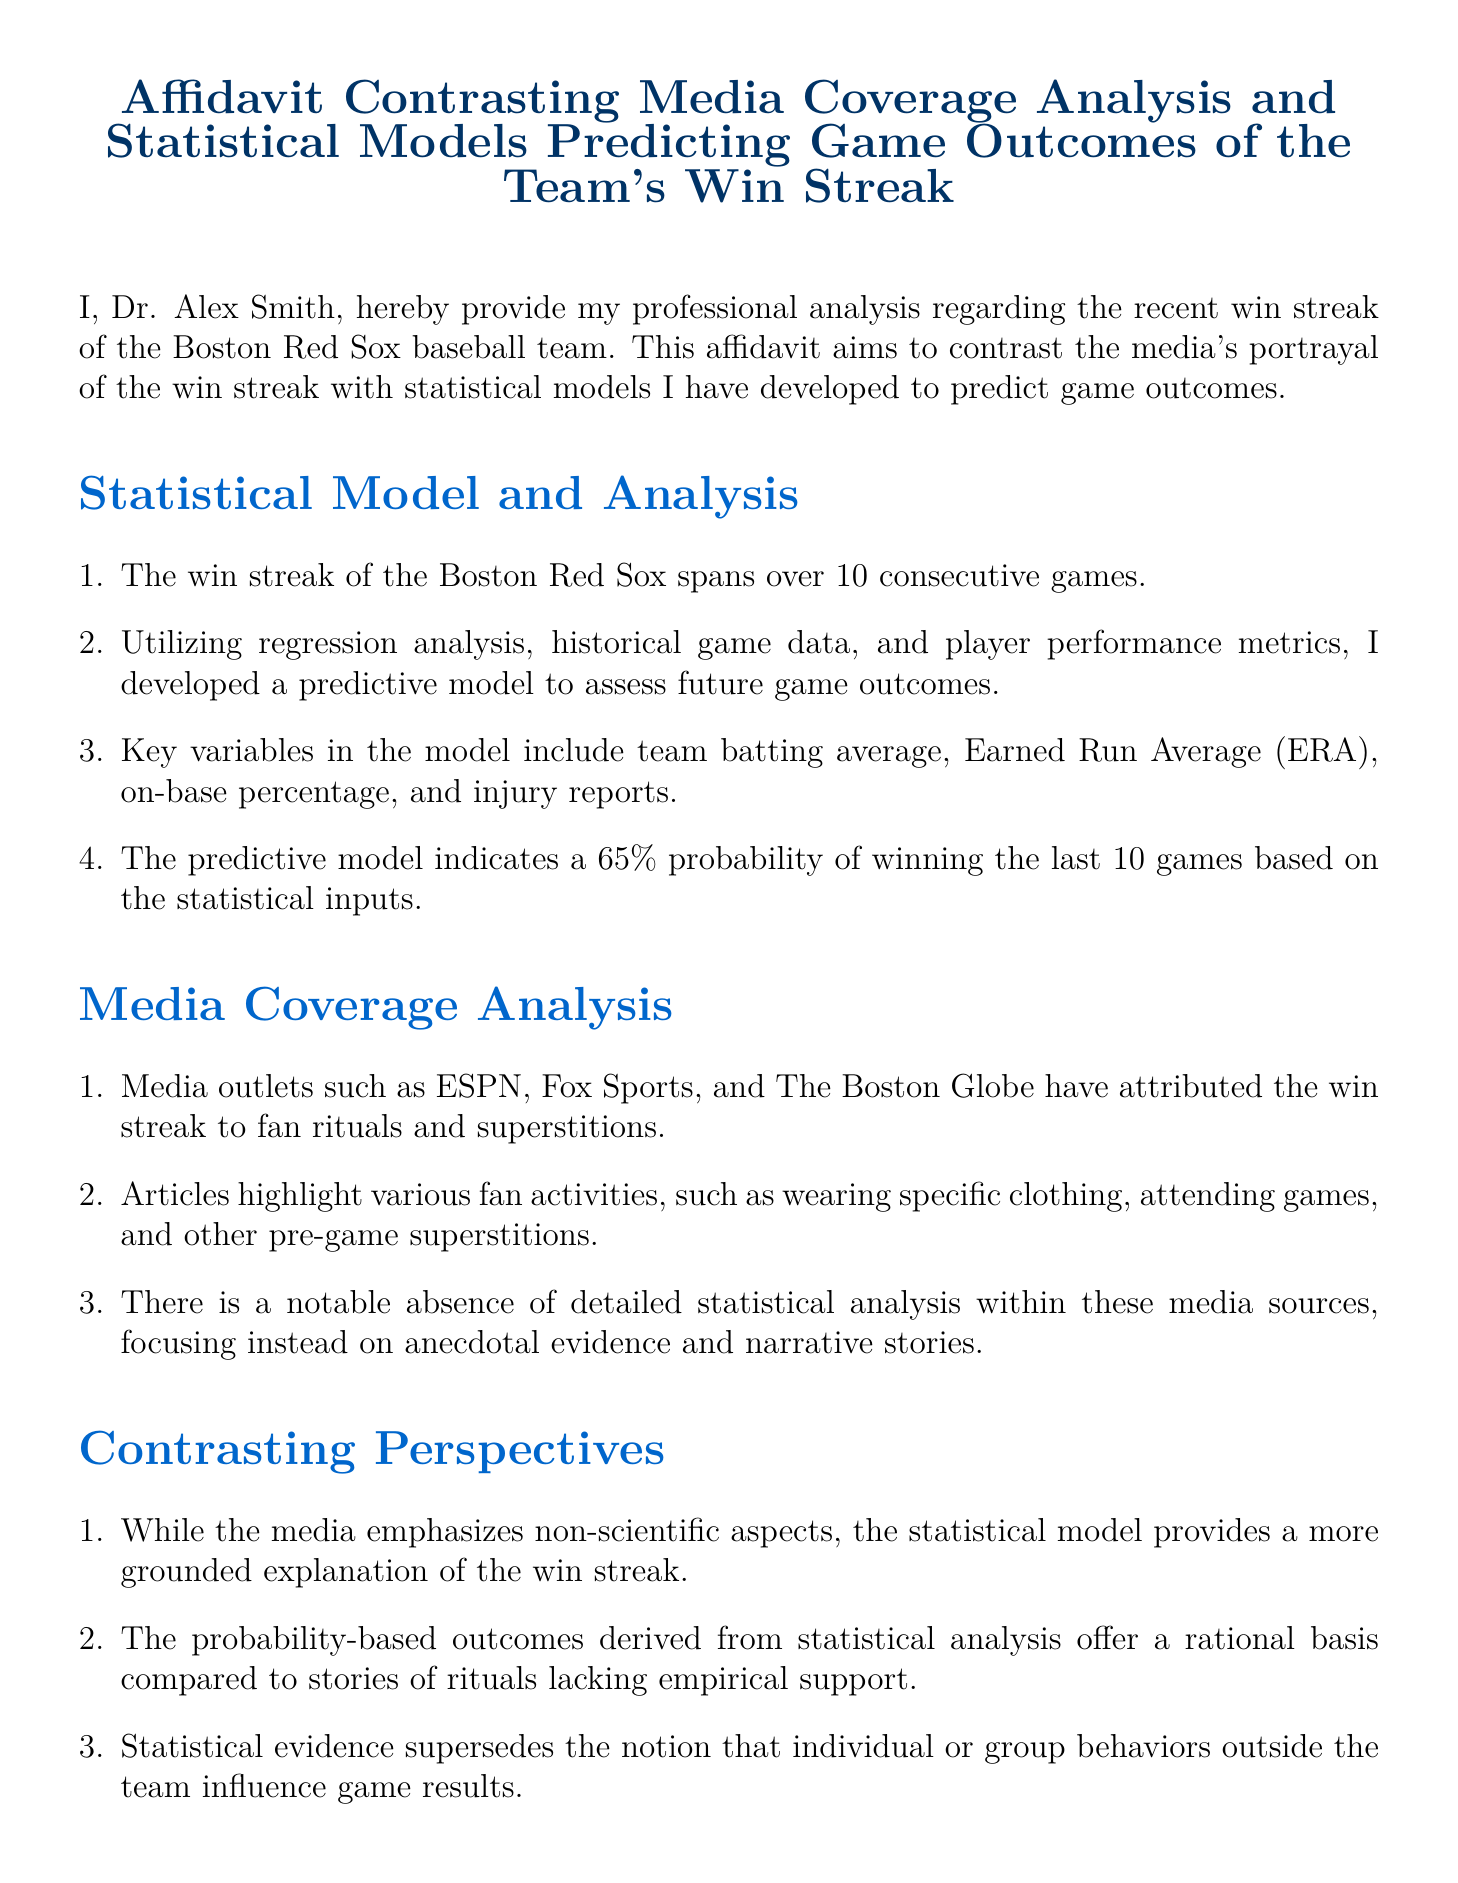What is the name of the affidavit's author? The author's name is mentioned at the beginning of the affidavit and is Dr. Alex Smith.
Answer: Dr. Alex Smith How long is the win streak of the Boston Red Sox? The document states that the win streak spans over 10 consecutive games.
Answer: 10 What statistical model prediction probability is mentioned for the team's win? The affidavit indicates a 65% probability of winning the last 10 games based on statistical inputs.
Answer: 65% Which media outlets are cited in the analysis? The affidavit lists ESPN, Fox Sports, and The Boston Globe as media outlets discussing the win streak.
Answer: ESPN, Fox Sports, The Boston Globe What key player metric is NOT included in the statistical model? The document does not mention runs batted in (RBI) as a key variable in the model.
Answer: Runs batted in What does the media emphasize as a reason for the team's success? The media highlights fan rituals and superstitions as the primary reasons for the team's win streak.
Answer: Fan rituals and superstitions What is the date on which the affidavit was signed? The affidavit includes the date when it was signed, which is listed as October 10, 2023.
Answer: October 10, 2023 How does the author perceive media narratives surrounding the win streak? The author suggests that media narratives lack empirical validation and should be considered supplementary.
Answer: Lack of empirical validation 